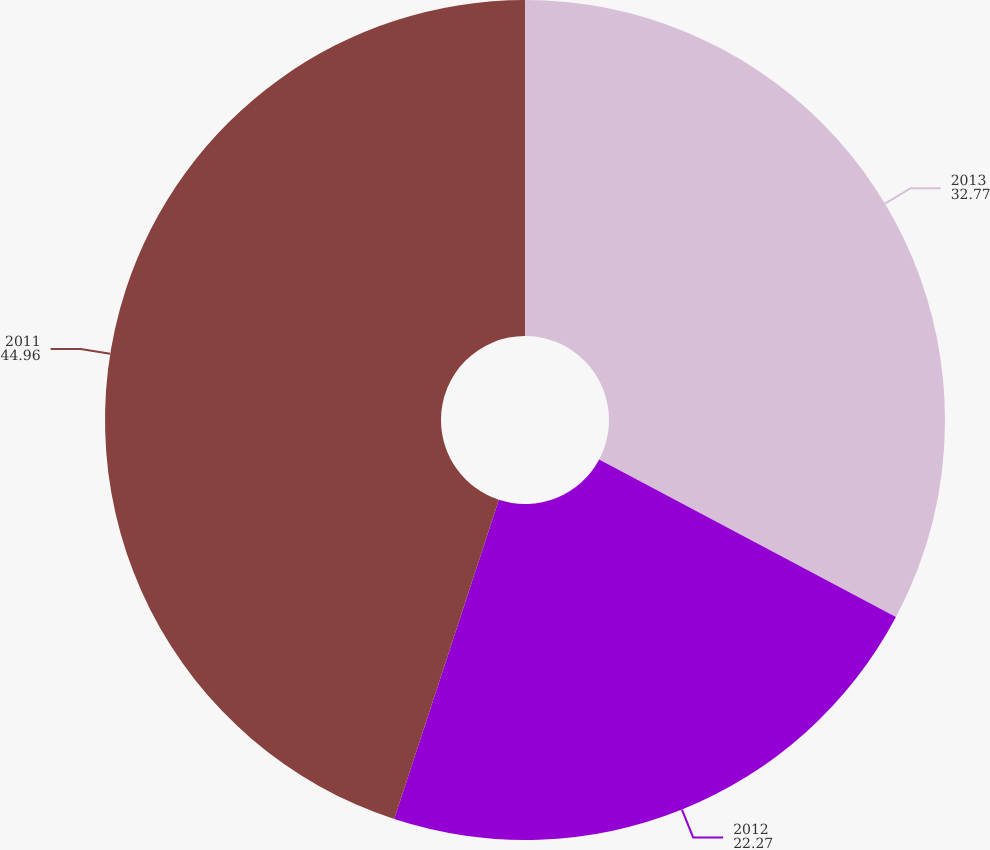Convert chart to OTSL. <chart><loc_0><loc_0><loc_500><loc_500><pie_chart><fcel>2013<fcel>2012<fcel>2011<nl><fcel>32.77%<fcel>22.27%<fcel>44.96%<nl></chart> 